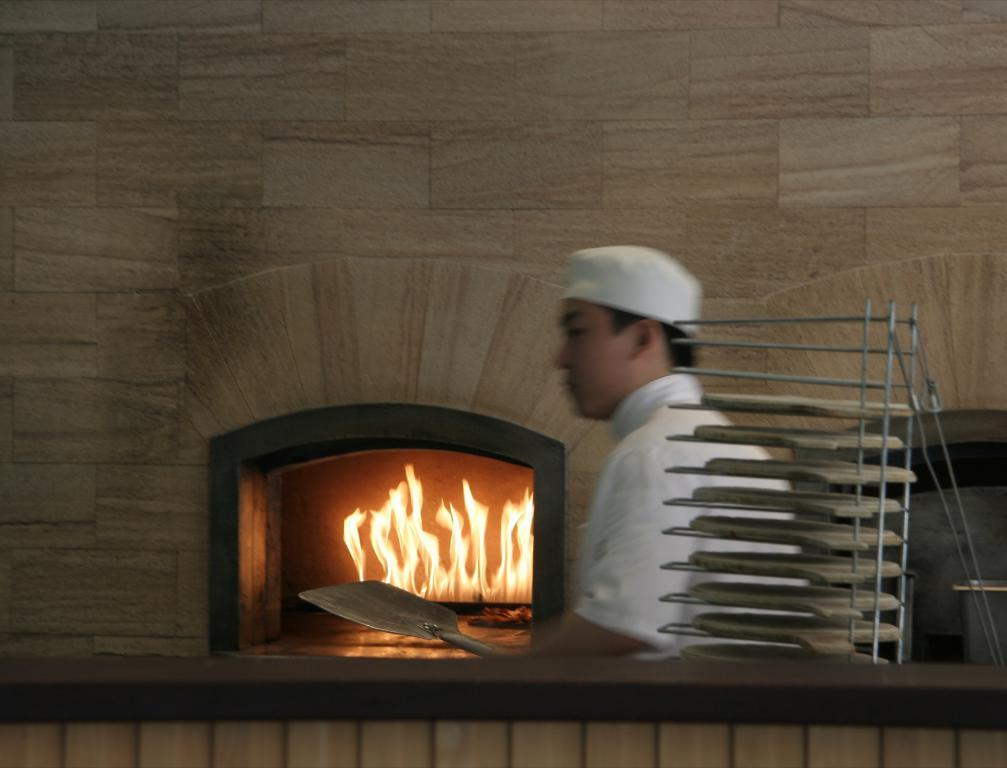What is the person in the image wearing on their head? The person in the image is wearing a cap. What can be seen in the image that might be used for displaying or serving items? There is a stand with trays in the image. What is the background of the image composed of? There is a wall in the background of the image. What is the source of heat or light in the image? There is fire in the image. Can you see any quicksand in the image? No, there is no quicksand present in the image. What type of quiver is the person holding in the image? There is no quiver present in the image; the person is wearing a cap. 